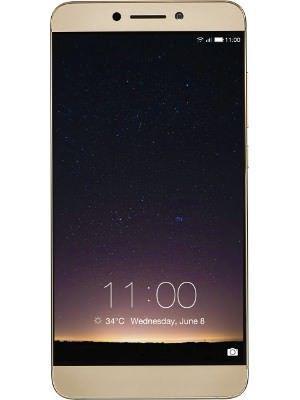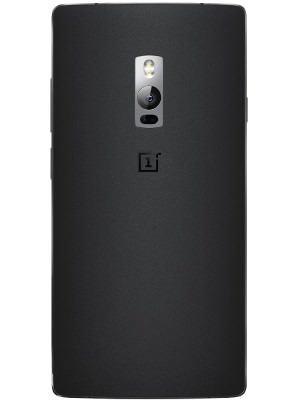The first image is the image on the left, the second image is the image on the right. Examine the images to the left and right. Is the description "Each image shows a device viewed head-on, and at least one of the images shows an overlapping device." accurate? Answer yes or no. No. The first image is the image on the left, the second image is the image on the right. Given the left and right images, does the statement "The phone screen is completely visible in each image." hold true? Answer yes or no. No. 